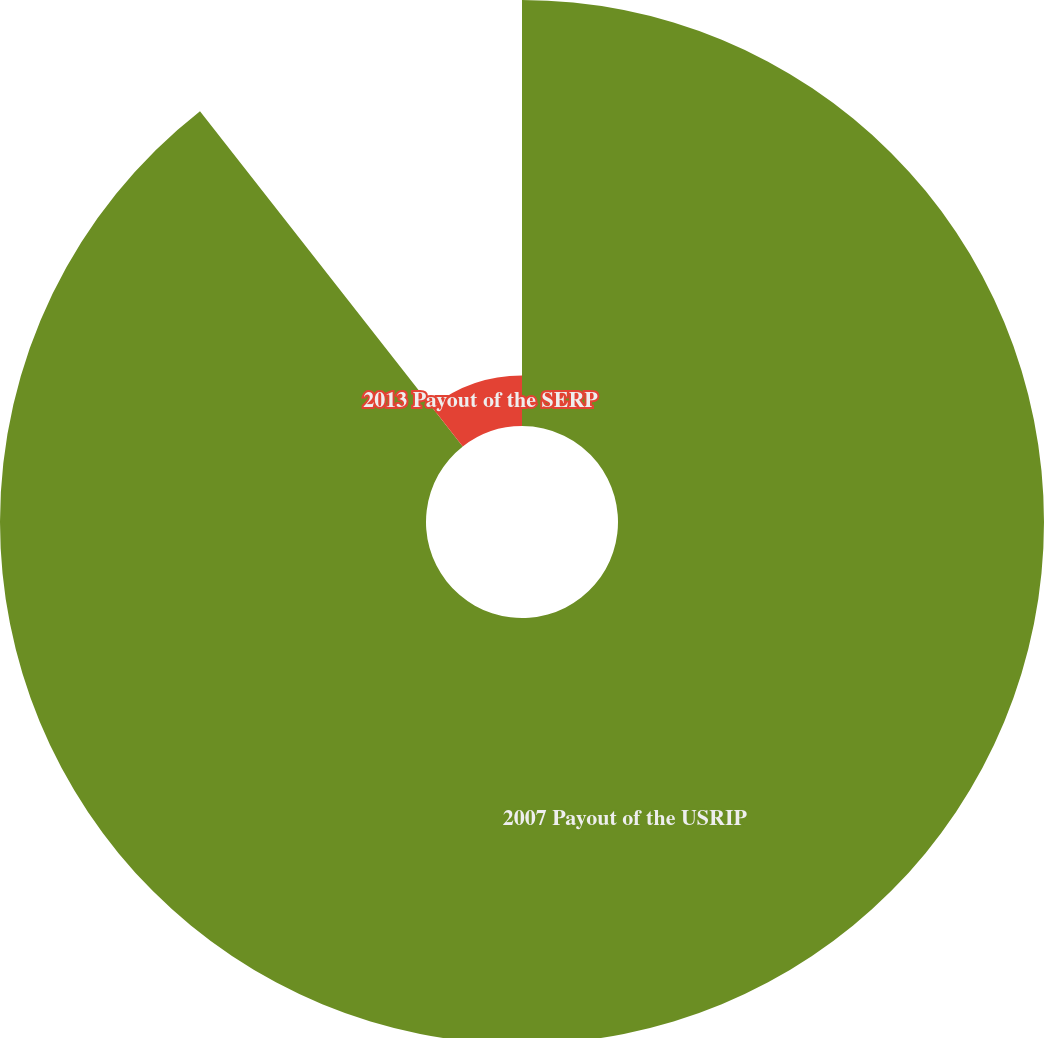<chart> <loc_0><loc_0><loc_500><loc_500><pie_chart><fcel>2007 Payout of the USRIP<fcel>2013 Payout of the SERP<nl><fcel>89.42%<fcel>10.58%<nl></chart> 